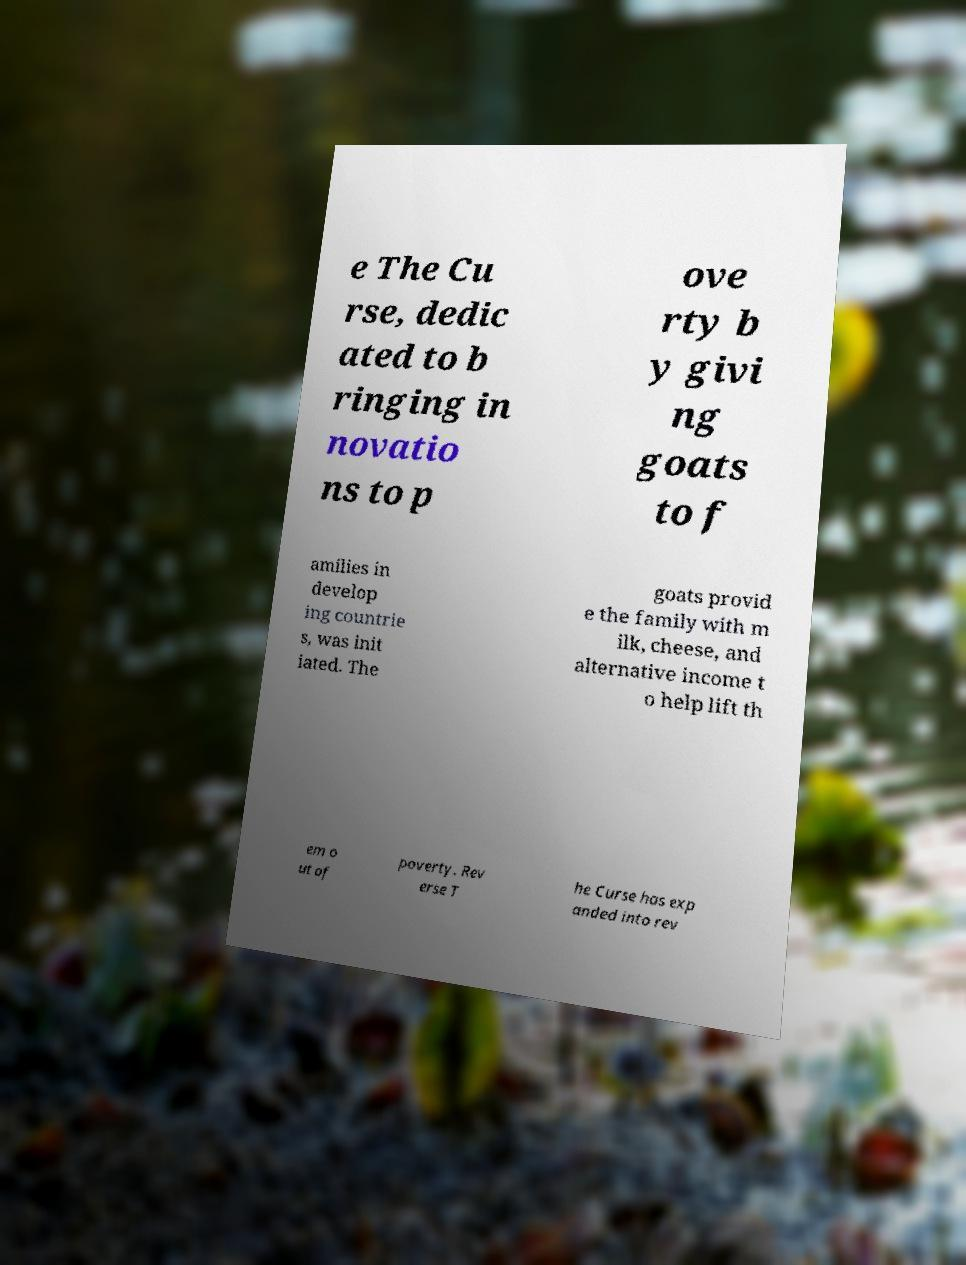Could you extract and type out the text from this image? e The Cu rse, dedic ated to b ringing in novatio ns to p ove rty b y givi ng goats to f amilies in develop ing countrie s, was init iated. The goats provid e the family with m ilk, cheese, and alternative income t o help lift th em o ut of poverty. Rev erse T he Curse has exp anded into rev 